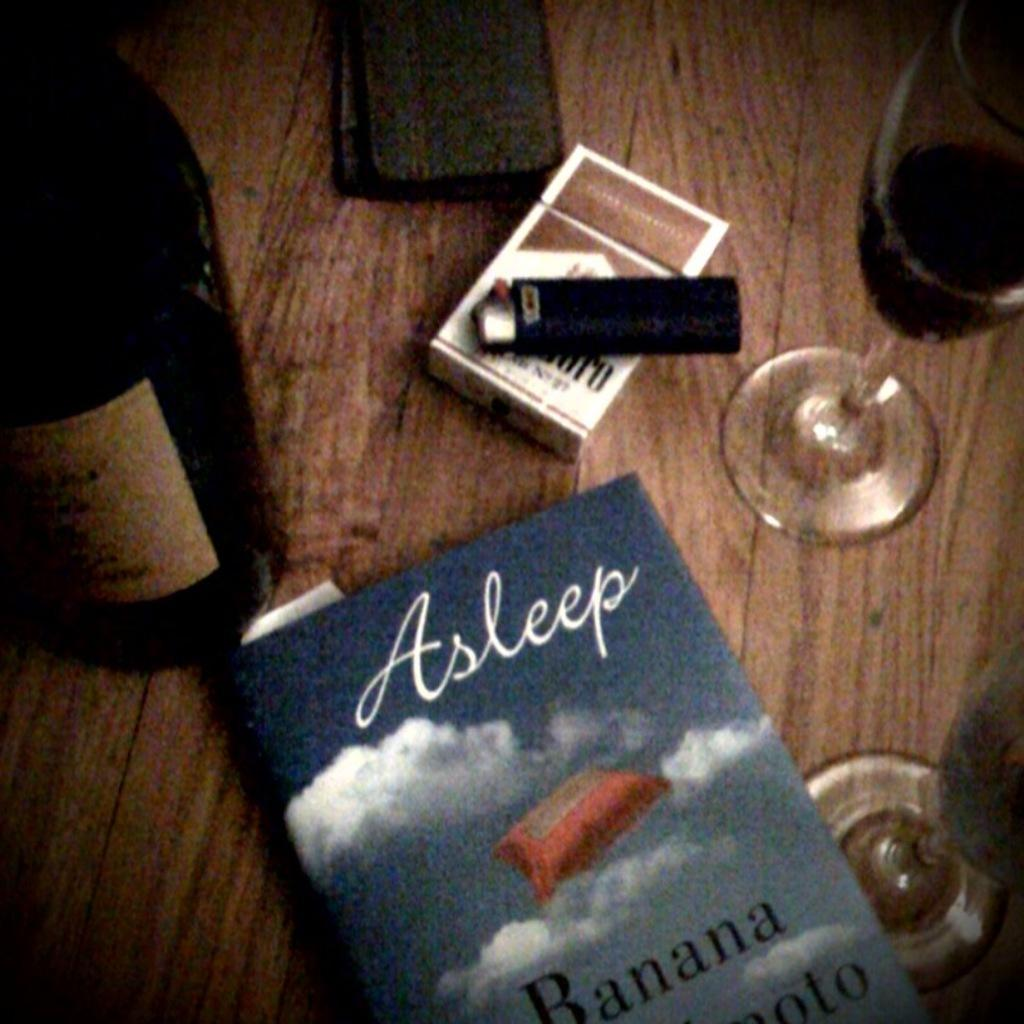<image>
Give a short and clear explanation of the subsequent image. a book that has clouds on it and is titled 'asleep' 